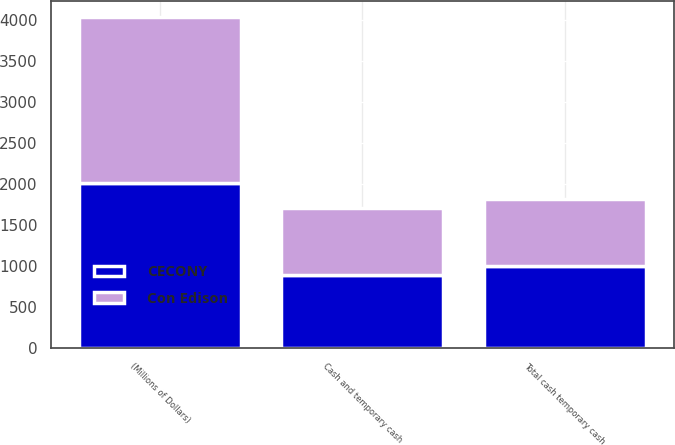<chart> <loc_0><loc_0><loc_500><loc_500><stacked_bar_chart><ecel><fcel>(Millions of Dollars)<fcel>Cash and temporary cash<fcel>Total cash temporary cash<nl><fcel>CECONY<fcel>2018<fcel>895<fcel>1006<nl><fcel>Con Edison<fcel>2018<fcel>818<fcel>818<nl></chart> 